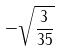<formula> <loc_0><loc_0><loc_500><loc_500>- \sqrt { \frac { 3 } { 3 5 } }</formula> 